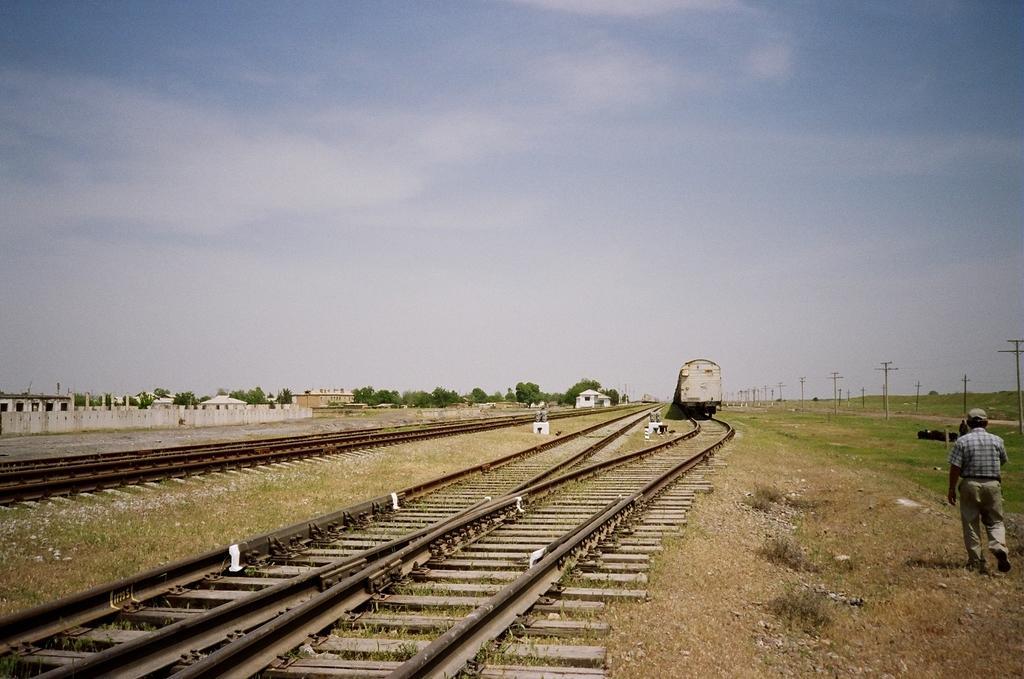How would you summarize this image in a sentence or two? There is a train on the track, a man is walking, there are trees and tracks, this is grass and a sky. 